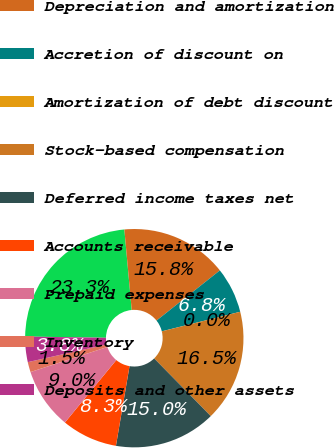Convert chart. <chart><loc_0><loc_0><loc_500><loc_500><pie_chart><fcel>Net income<fcel>Depreciation and amortization<fcel>Accretion of discount on<fcel>Amortization of debt discount<fcel>Stock-based compensation<fcel>Deferred income taxes net<fcel>Accounts receivable<fcel>Prepaid expenses<fcel>Inventory<fcel>Deposits and other assets<nl><fcel>23.31%<fcel>15.79%<fcel>6.77%<fcel>0.0%<fcel>16.54%<fcel>15.04%<fcel>8.27%<fcel>9.02%<fcel>1.5%<fcel>3.76%<nl></chart> 